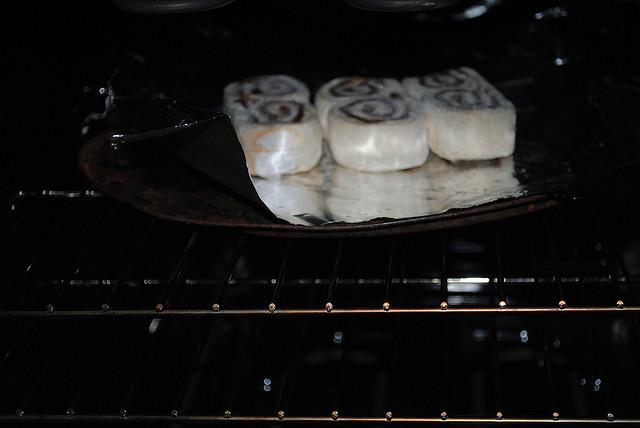Why are the cinnamon buns white? Please explain your reasoning. icing. The white color on top of these uncooked buns is icing. 